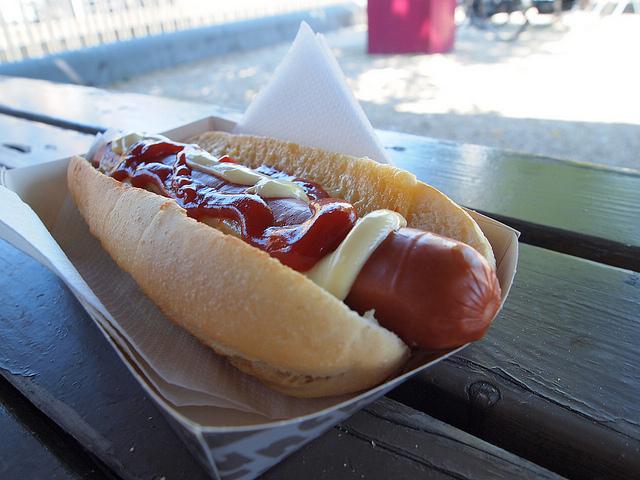How much does this hotdog cost?
Quick response, please. 2.00. Is there ketchup on the hot dog?
Answer briefly. Yes. What is under the food?
Be succinct. Napkin. Is the hot dog in a bun?
Write a very short answer. Yes. 